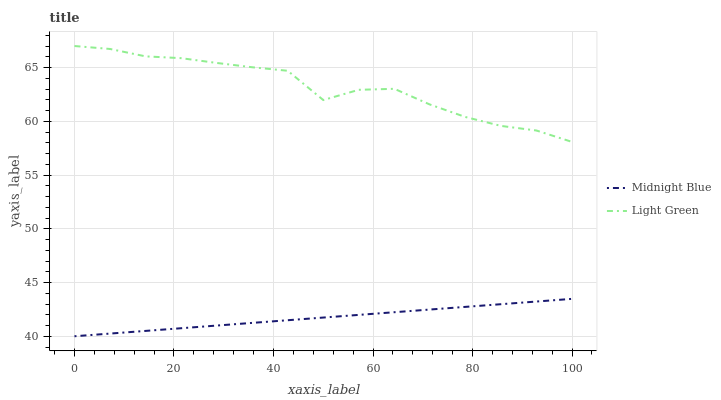Does Midnight Blue have the minimum area under the curve?
Answer yes or no. Yes. Does Light Green have the maximum area under the curve?
Answer yes or no. Yes. Does Light Green have the minimum area under the curve?
Answer yes or no. No. Is Midnight Blue the smoothest?
Answer yes or no. Yes. Is Light Green the roughest?
Answer yes or no. Yes. Is Light Green the smoothest?
Answer yes or no. No. Does Midnight Blue have the lowest value?
Answer yes or no. Yes. Does Light Green have the lowest value?
Answer yes or no. No. Does Light Green have the highest value?
Answer yes or no. Yes. Is Midnight Blue less than Light Green?
Answer yes or no. Yes. Is Light Green greater than Midnight Blue?
Answer yes or no. Yes. Does Midnight Blue intersect Light Green?
Answer yes or no. No. 